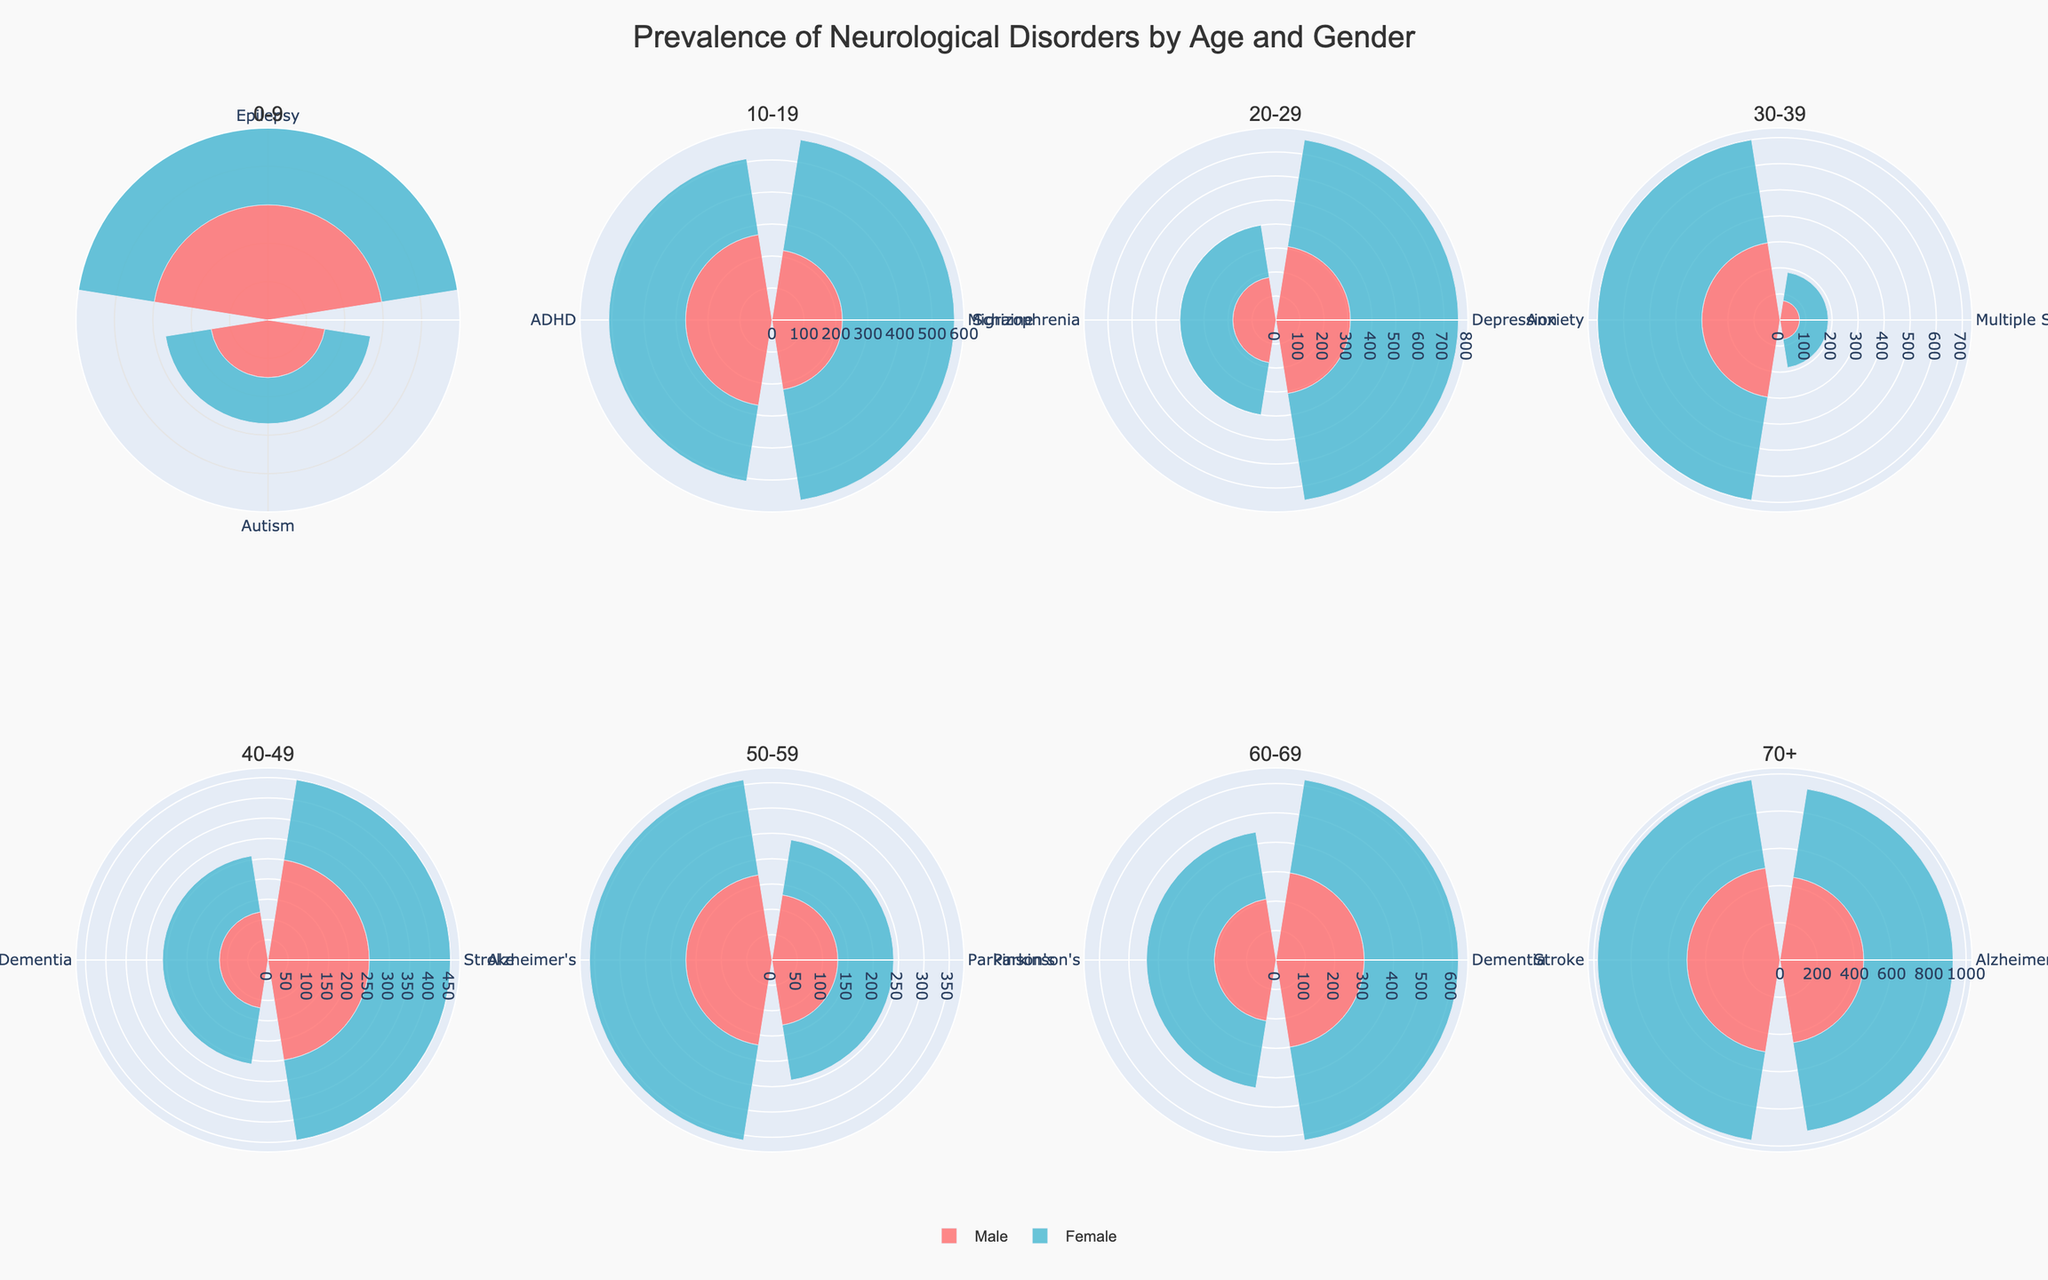Which neurological disorder has the highest prevalence in the 70+ age group for both genders? In the 70+ age group, looking at both Male and Female segments, Alzheimer's has a combined high prevalence for both genders with prevalences of 450 and 480 respectively. Thus, Alzheimer's stands out as the most prevalent.
Answer: Alzheimer's What is the total prevalence of Epilepsy in the 0-9 age group? To find the total prevalence, add the prevalence rates for both genders. For males, it is 300 and for females, it is 280. Adding these together gives 300 + 280 = 580.
Answer: 580 Which gender has a higher prevalence of Depression in the 20-29 age group? For the 20-29 age group, compare the prevalence of Depression between males and females. Males have 310 while females have 450. Hence, females have a higher prevalence.
Answer: Female How does the prevalence of Autism differ between males and females in the 0-9 age group? Check the prevalence of Autism in both males and females in the 0-9 age group. Males have a prevalence of 150 and females have 120. The difference is 150 - 120 = 30, with males having a higher prevalence.
Answer: 30 What's the average prevalence of neurological disorders in the 50-59 age group for males? In the 50-59 age group for males, find the prevalence values for all listed disorders which are Parkinson's (130) and Alzheimer's (170). The total prevalence is 130 + 170 = 300. The average is 300 / 2 = 150.
Answer: 150 Which gender has a higher prevalence of Stroke in the 40-49 age group? In the 40-49 age group, males have a prevalence of 250, while females have 200 for Stroke. Thus, males have a higher prevalence.
Answer: Male Compare the prevalence of Anxiety between males and females in the 30-39 age group. In the 30-39 age group, Anxiety has prevalence rates of 300 for males and 400 for females. Comparing these, females have a higher prevalence.
Answer: Female What is the difference in the prevalence of Dementia between the 60-69 and 40-49 age groups for females? For females, the prevalence of Dementia in the 60-69 age group is 320 and in the 40-49 age group, it's 140. The difference is 320 - 140 = 180.
Answer: 180 What is the combined prevalence of Parkinson's for both genders in the 60-69 age group? Add the prevalence rates of Parkinson's for males (210) and females (230) in the 60-69 age group. The combined prevalence is 210 + 230 = 440.
Answer: 440 